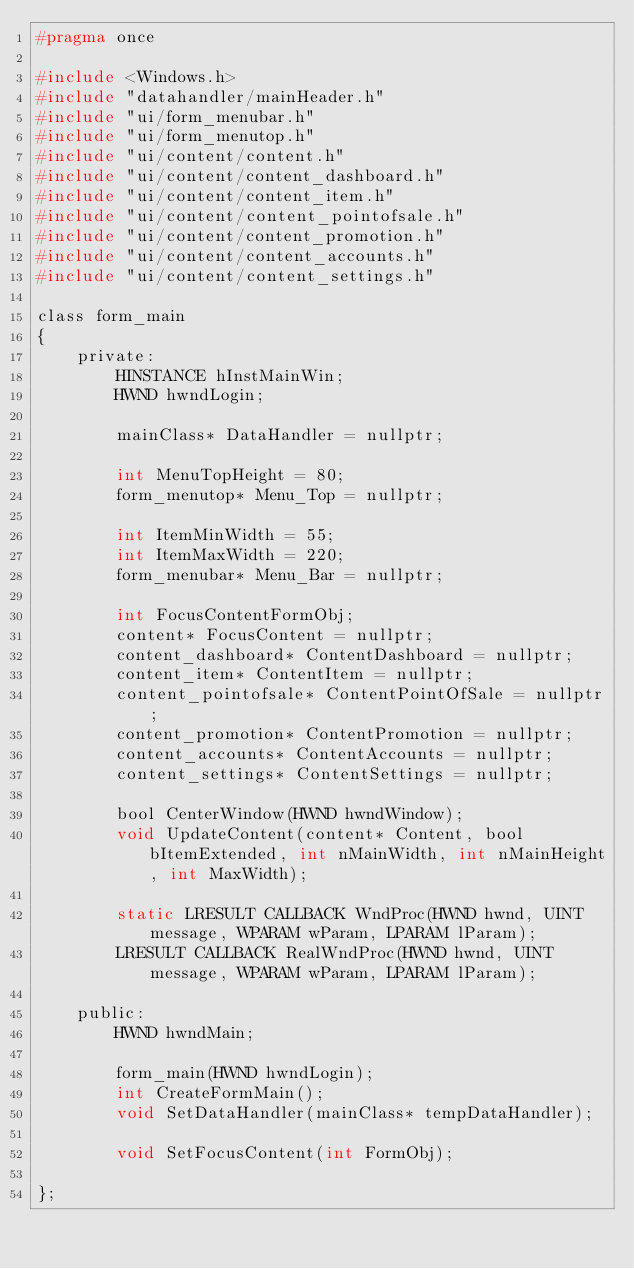<code> <loc_0><loc_0><loc_500><loc_500><_C_>#pragma once

#include <Windows.h>
#include "datahandler/mainHeader.h"
#include "ui/form_menubar.h"
#include "ui/form_menutop.h"
#include "ui/content/content.h"
#include "ui/content/content_dashboard.h"
#include "ui/content/content_item.h"
#include "ui/content/content_pointofsale.h"
#include "ui/content/content_promotion.h"
#include "ui/content/content_accounts.h"
#include "ui/content/content_settings.h"

class form_main
{
    private:
        HINSTANCE hInstMainWin;
        HWND hwndLogin;

        mainClass* DataHandler = nullptr;

        int MenuTopHeight = 80;
        form_menutop* Menu_Top = nullptr;

        int ItemMinWidth = 55;
        int ItemMaxWidth = 220;
        form_menubar* Menu_Bar = nullptr;

        int FocusContentFormObj;
        content* FocusContent = nullptr;
        content_dashboard* ContentDashboard = nullptr;
        content_item* ContentItem = nullptr;
        content_pointofsale* ContentPointOfSale = nullptr;
        content_promotion* ContentPromotion = nullptr;
        content_accounts* ContentAccounts = nullptr;
        content_settings* ContentSettings = nullptr;

        bool CenterWindow(HWND hwndWindow);
        void UpdateContent(content* Content, bool bItemExtended, int nMainWidth, int nMainHeight, int MaxWidth);

        static LRESULT CALLBACK WndProc(HWND hwnd, UINT message, WPARAM wParam, LPARAM lParam);
        LRESULT CALLBACK RealWndProc(HWND hwnd, UINT message, WPARAM wParam, LPARAM lParam);

    public:
        HWND hwndMain;

        form_main(HWND hwndLogin);
        int CreateFormMain();
        void SetDataHandler(mainClass* tempDataHandler);

        void SetFocusContent(int FormObj);
        
};</code> 